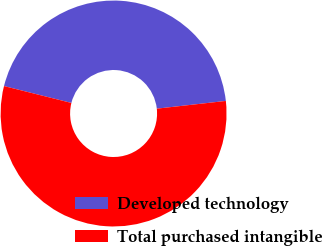<chart> <loc_0><loc_0><loc_500><loc_500><pie_chart><fcel>Developed technology<fcel>Total purchased intangible<nl><fcel>44.32%<fcel>55.68%<nl></chart> 